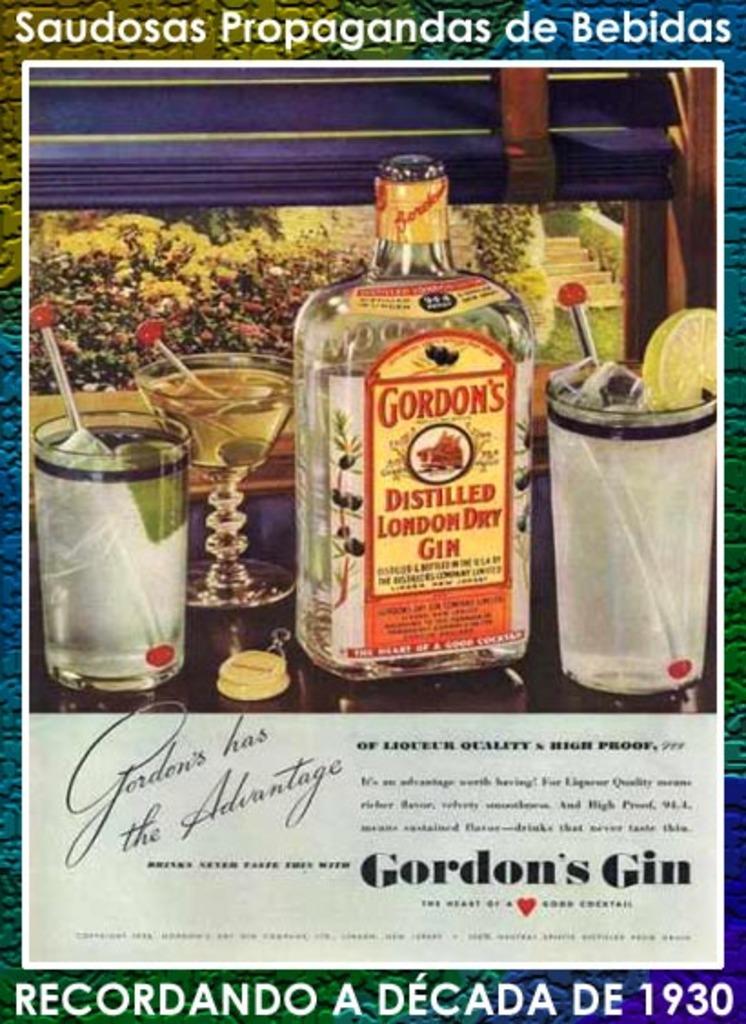What type of gin is gordon's?
Ensure brevity in your answer.  Distilled london dry. 